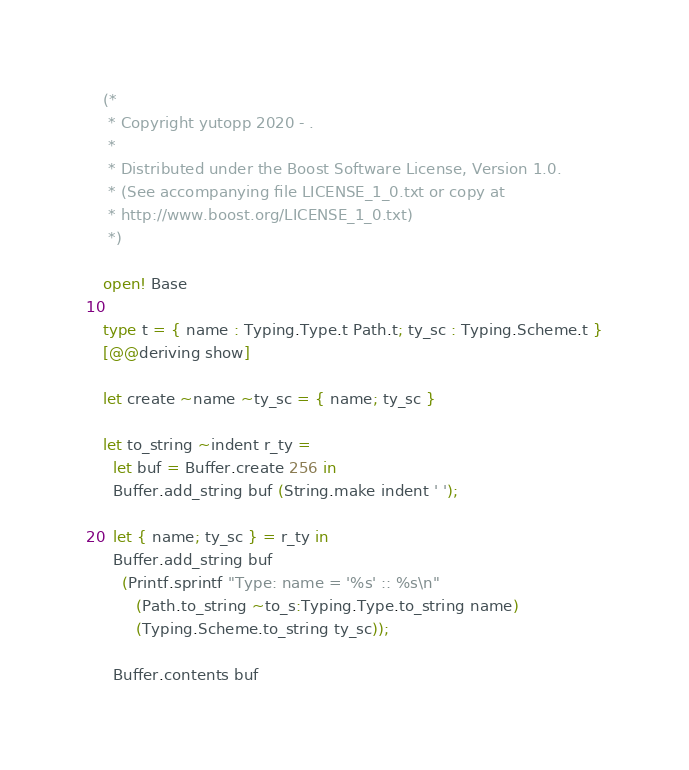<code> <loc_0><loc_0><loc_500><loc_500><_OCaml_>(*
 * Copyright yutopp 2020 - .
 *
 * Distributed under the Boost Software License, Version 1.0.
 * (See accompanying file LICENSE_1_0.txt or copy at
 * http://www.boost.org/LICENSE_1_0.txt)
 *)

open! Base

type t = { name : Typing.Type.t Path.t; ty_sc : Typing.Scheme.t }
[@@deriving show]

let create ~name ~ty_sc = { name; ty_sc }

let to_string ~indent r_ty =
  let buf = Buffer.create 256 in
  Buffer.add_string buf (String.make indent ' ');

  let { name; ty_sc } = r_ty in
  Buffer.add_string buf
    (Printf.sprintf "Type: name = '%s' :: %s\n"
       (Path.to_string ~to_s:Typing.Type.to_string name)
       (Typing.Scheme.to_string ty_sc));

  Buffer.contents buf
</code> 